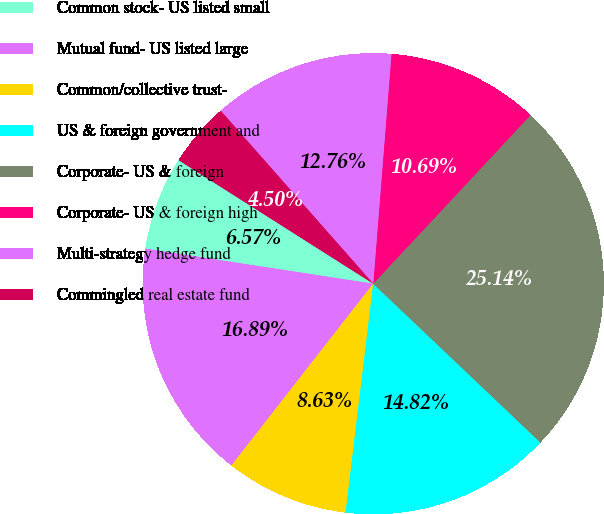Convert chart to OTSL. <chart><loc_0><loc_0><loc_500><loc_500><pie_chart><fcel>Common stock- US listed small<fcel>Mutual fund- US listed large<fcel>Common/collective trust-<fcel>US & foreign government and<fcel>Corporate- US & foreign<fcel>Corporate- US & foreign high<fcel>Multi-strategy hedge fund<fcel>Commingled real estate fund<nl><fcel>6.57%<fcel>16.89%<fcel>8.63%<fcel>14.82%<fcel>25.14%<fcel>10.69%<fcel>12.76%<fcel>4.5%<nl></chart> 